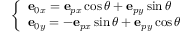Convert formula to latex. <formula><loc_0><loc_0><loc_500><loc_500>\left \{ \begin{array} { l l } { e _ { 0 x } = e _ { p x } \cos \theta + e _ { p y } \sin \theta } \\ { e _ { 0 y } = - e _ { p x } \sin \theta + e _ { p y } \cos \theta } \end{array}</formula> 